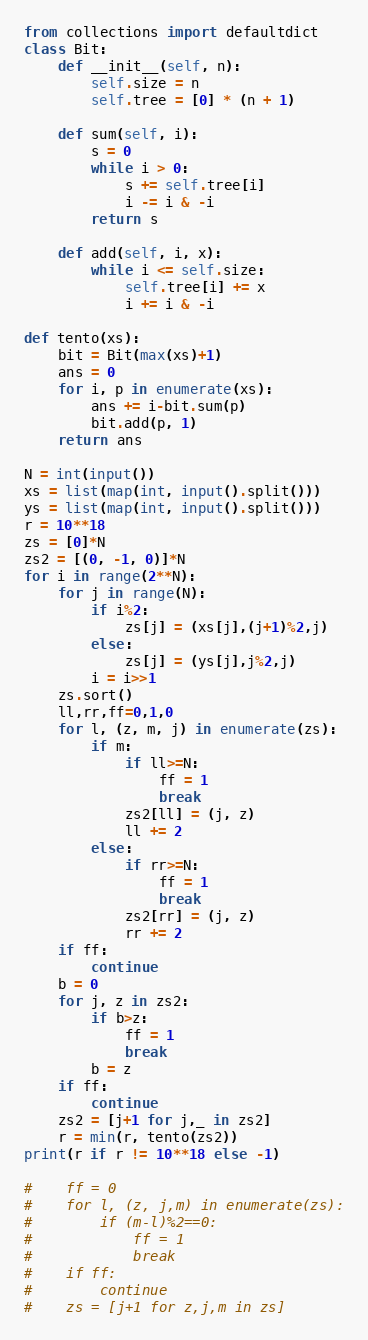Convert code to text. <code><loc_0><loc_0><loc_500><loc_500><_Python_>from collections import defaultdict
class Bit:
    def __init__(self, n):
        self.size = n
        self.tree = [0] * (n + 1)

    def sum(self, i):
        s = 0
        while i > 0:
            s += self.tree[i]
            i -= i & -i
        return s

    def add(self, i, x):
        while i <= self.size:
            self.tree[i] += x
            i += i & -i

def tento(xs):
    bit = Bit(max(xs)+1)
    ans = 0
    for i, p in enumerate(xs):
        ans += i-bit.sum(p)
        bit.add(p, 1)
    return ans

N = int(input())
xs = list(map(int, input().split()))
ys = list(map(int, input().split()))
r = 10**18
zs = [0]*N
zs2 = [(0, -1, 0)]*N
for i in range(2**N):
    for j in range(N):
        if i%2:
            zs[j] = (xs[j],(j+1)%2,j)
        else:
            zs[j] = (ys[j],j%2,j)
        i = i>>1
    zs.sort()
    ll,rr,ff=0,1,0
    for l, (z, m, j) in enumerate(zs):
        if m:
            if ll>=N:
                ff = 1
                break
            zs2[ll] = (j, z)
            ll += 2
        else:
            if rr>=N:
                ff = 1
                break
            zs2[rr] = (j, z)
            rr += 2
    if ff:
        continue
    b = 0
    for j, z in zs2:
        if b>z:
            ff = 1
            break
        b = z
    if ff:
        continue
    zs2 = [j+1 for j,_ in zs2]
    r = min(r, tento(zs2))
print(r if r != 10**18 else -1)

#    ff = 0
#    for l, (z, j,m) in enumerate(zs):
#        if (m-l)%2==0: 
#            ff = 1
#            break
#    if ff:
#        continue
#    zs = [j+1 for z,j,m in zs]
</code> 